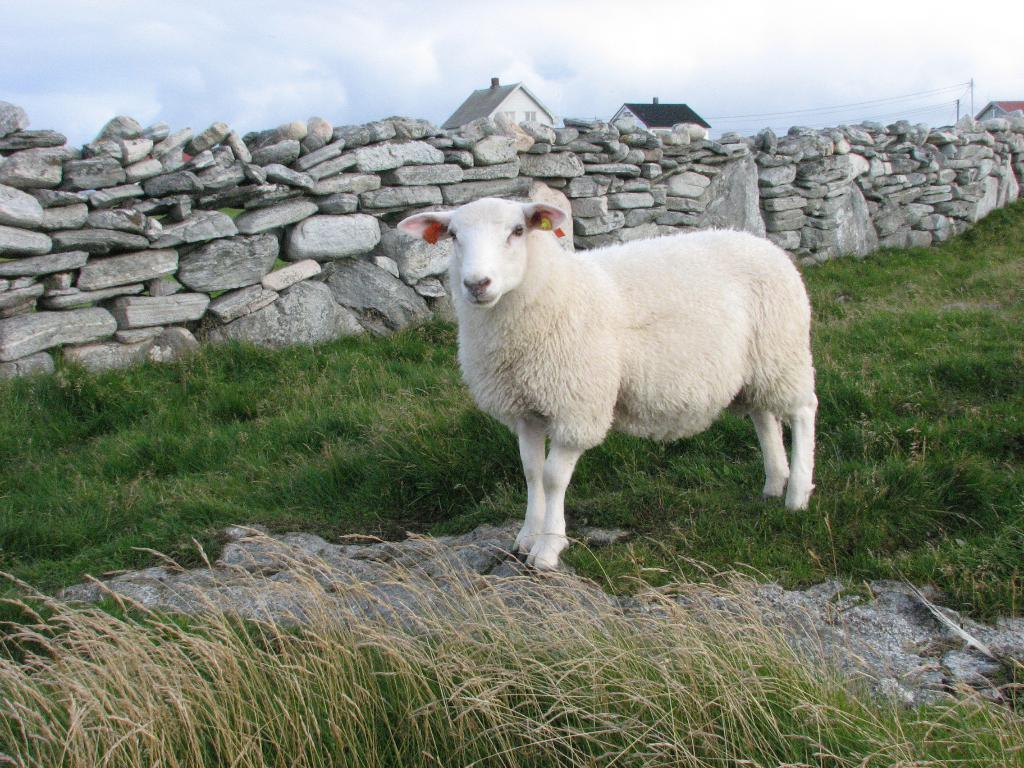What type of animal is in the image? There is a white-colored sheep in the image. What is the sheep standing on? The sheep is on the grass. What can be seen in the middle of the image? There are stones in the middle of the image. What is visible in the background of the image? There are houses in the background of the image. What is visible at the top of the image? The sky is visible at the top of the image. How many oranges are being harvested by the sheep in the image? There are no oranges present in the image, and the sheep is not harvesting anything. What type of farming equipment is being used by the sheep in the image? There is no farming equipment present in the image, and the sheep is not using any tools. 